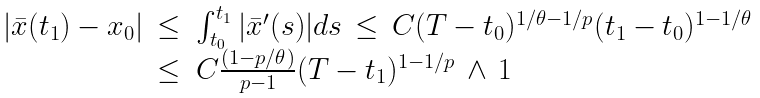Convert formula to latex. <formula><loc_0><loc_0><loc_500><loc_500>\begin{array} { r l } | \bar { x } ( t _ { 1 } ) - x _ { 0 } | \, \leq & \int _ { t _ { 0 } } ^ { t _ { 1 } } | \bar { x } ^ { \prime } ( s ) | d s \, \leq \, C ( T - t _ { 0 } ) ^ { 1 / \theta - 1 / p } ( t _ { 1 } - t _ { 0 } ) ^ { 1 - 1 / \theta } \\ \leq & C \frac { ( 1 - p / \theta ) } { p - 1 } ( T - t _ { 1 } ) ^ { 1 - 1 / p } \, \wedge \, 1 \end{array}</formula> 